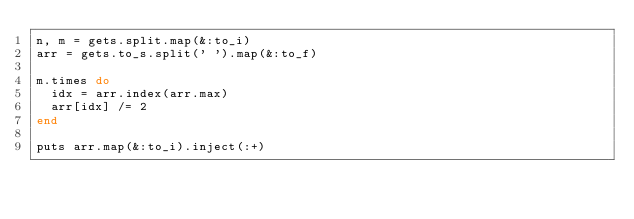Convert code to text. <code><loc_0><loc_0><loc_500><loc_500><_Ruby_>n, m = gets.split.map(&:to_i)
arr = gets.to_s.split(' ').map(&:to_f)

m.times do
  idx = arr.index(arr.max)
  arr[idx] /= 2
end

puts arr.map(&:to_i).inject(:+)</code> 